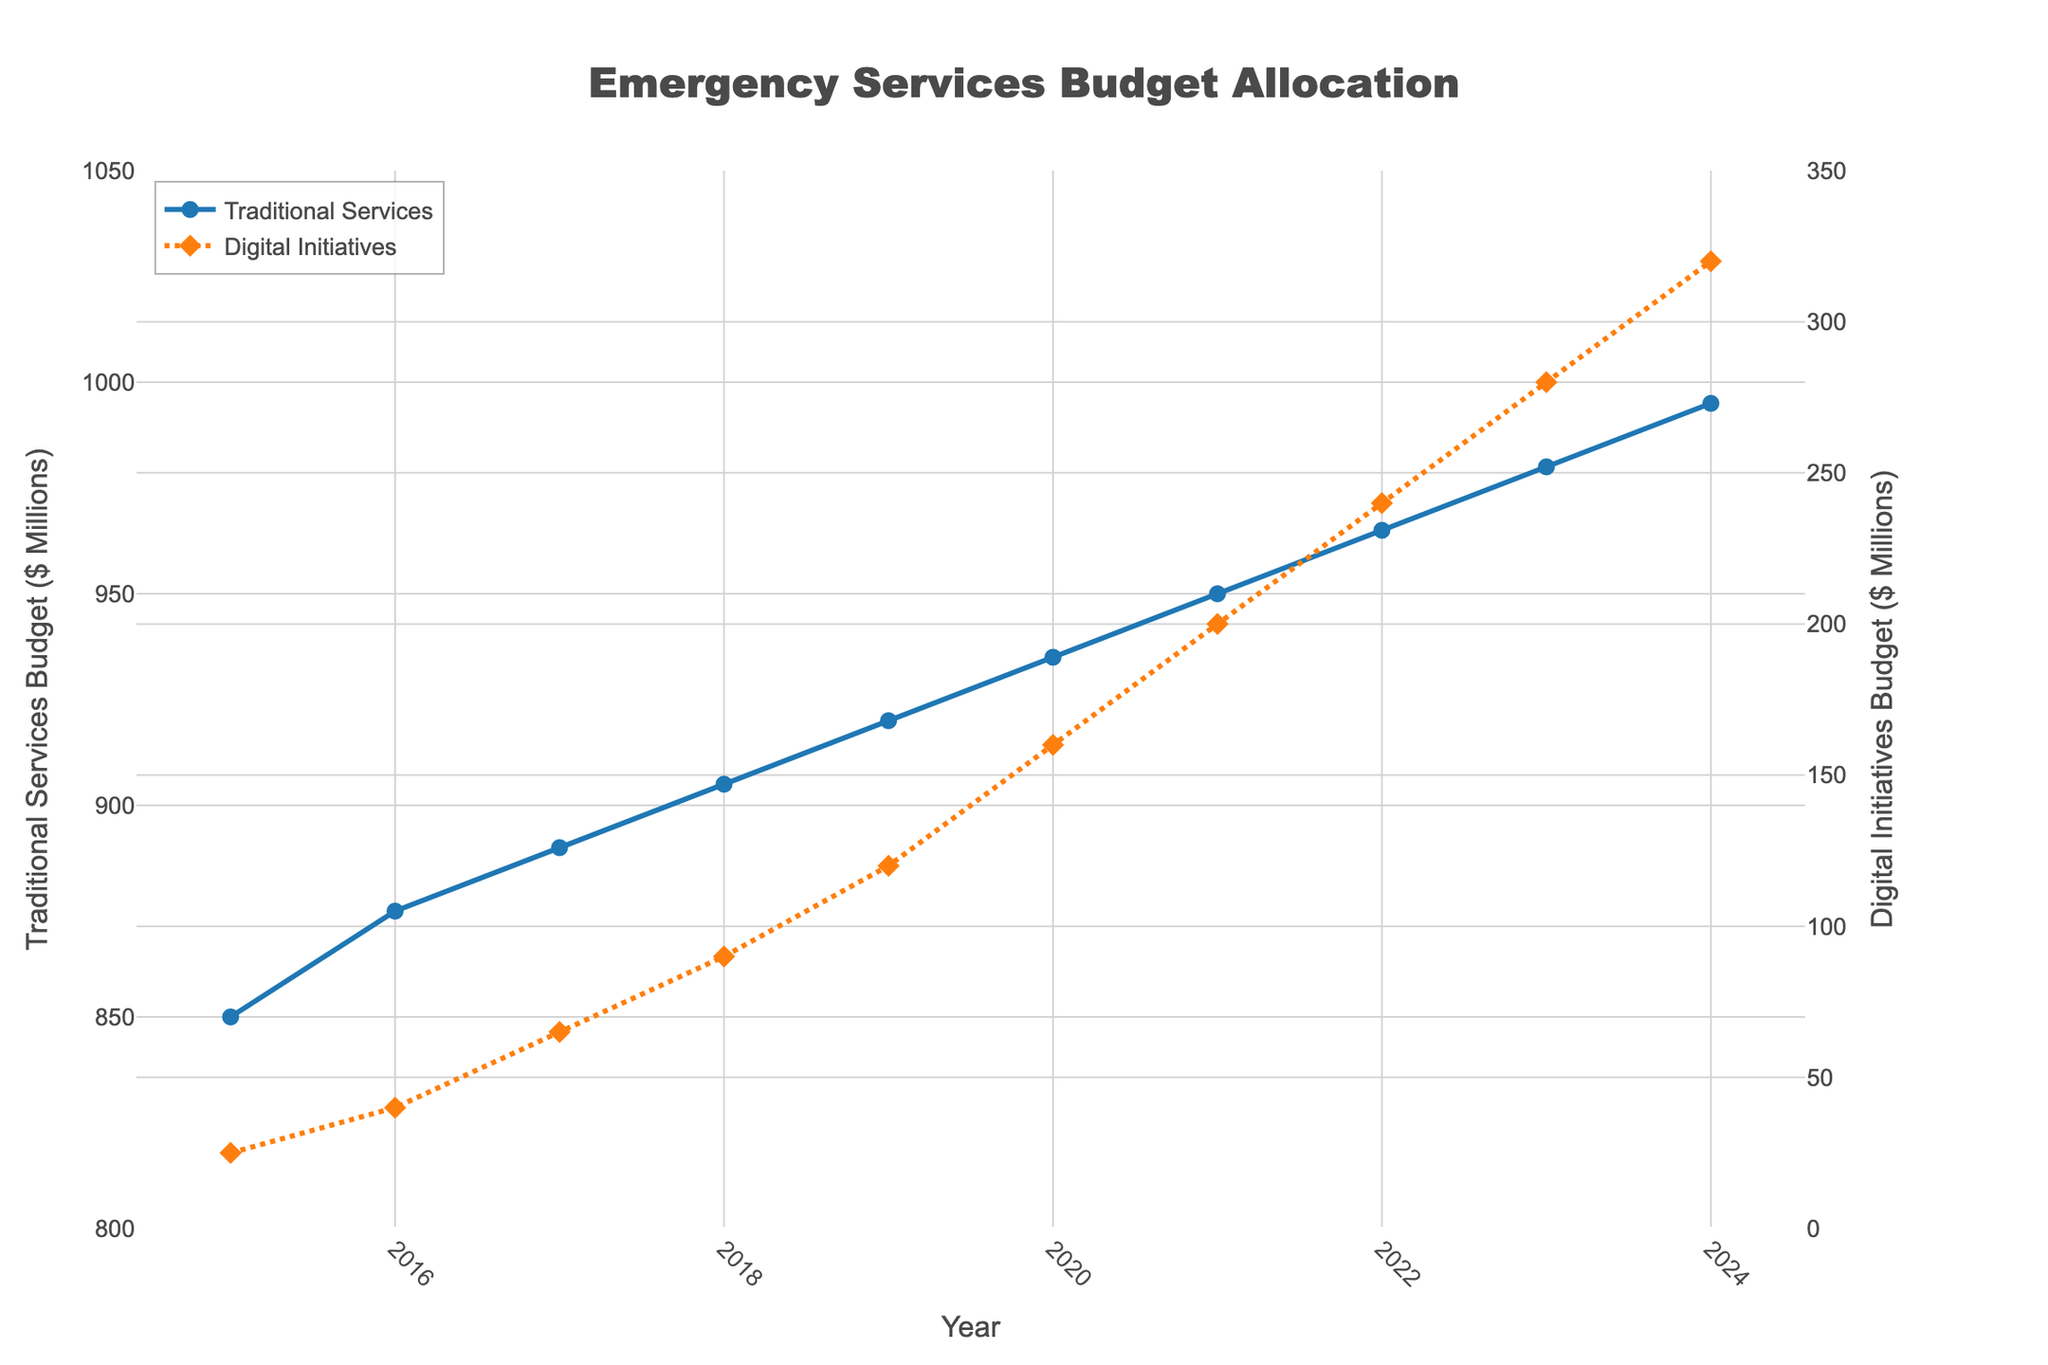Which year had the highest budget for both traditional emergency services and digital initiatives? From the graph, the highest budget for both services seems to be in 2024. The traditional services budget is around $995 million and the digital initiatives budget is around $320 million, both peaking in 2024.
Answer: 2024 Which budget has grown at a faster rate over the years, traditional services or digital initiatives? To determine the faster growth rate, observe the slopes of the lines. The digital initiatives budget line has a steeper slope compared to the traditional services budget line, indicating a faster rate of increase.
Answer: Digital initiatives What is the difference in budget allocation for digital initiatives between 2018 and 2023? The digital initiatives budget in 2018 is approximately $90 million, and in 2023 it is about $280 million. The difference is $280 million - $90 million = $190 million.
Answer: $190 million In which year did the digital initiatives budget exceed $150 million? Refer to the digital initiatives budget line and find the year it first exceeds $150 million. This occurs in the year 2020 with a budget of $160 million.
Answer: 2020 How much combined funding was allocated to both traditional and digital services in 2021? Combine the traditional and digital services budgets for 2021. Traditional services have $950 million and digital initiatives have $200 million. The total is $950 million + $200 million = $1150 million.
Answer: $1150 million How has the funding gap between traditional emergency services and digital initiatives changed from 2015 to 2024? Calculate the funding gap for both years. In 2015: $850 million - $25 million = $825 million. In 2024: $995 million - $320 million = $675 million. The gap has decreased from $825 million to $675 million between 2015 and 2024.
Answer: Decreased by $150 million Which year saw the smallest difference in budget between traditional and digital services? Identify the smallest gap by comparing the differences each year. In 2024, the difference is minimal: $995 million - $320 million = $675 million, which appears to be the smallest compared to other years.
Answer: 2024 What is the total budget for digital initiatives over the 10-year period from 2015 to 2024? Add the digital initiatives budget for each year from 2015 to 2024. Summing them up: $25M + $40M + $65M + $90M + $120M + $160M + $200M + $240M + $280M + $320M = $1540 million.
Answer: $1540 million Which service saw the most consistent budget increase year over year? Consistency in increase can be seen by observing the smoothness and steadiness of the line’s slope. The traditional emergency services budget line shows a steadier, more consistent increase compared to the digital initiatives budget line, which has more variance.
Answer: Traditional emergency services 